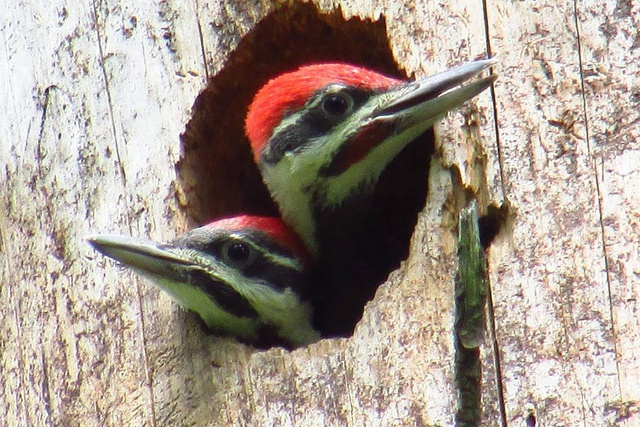Describe the objects in this image and their specific colors. I can see bird in white, black, darkgreen, gray, and salmon tones and bird in white, black, gray, darkgreen, and darkgray tones in this image. 